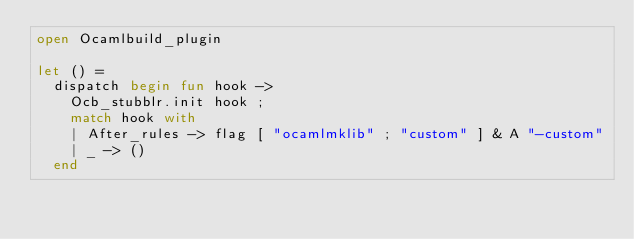Convert code to text. <code><loc_0><loc_0><loc_500><loc_500><_OCaml_>open Ocamlbuild_plugin

let () =
  dispatch begin fun hook ->
    Ocb_stubblr.init hook ;
    match hook with
    | After_rules -> flag [ "ocamlmklib" ; "custom" ] & A "-custom"
    | _ -> ()
  end
</code> 